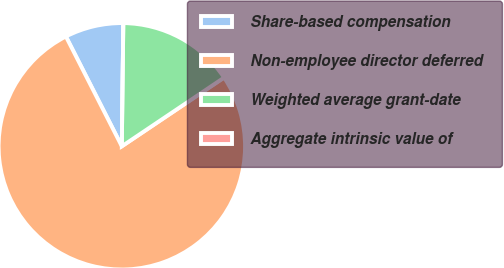Convert chart. <chart><loc_0><loc_0><loc_500><loc_500><pie_chart><fcel>Share-based compensation<fcel>Non-employee director deferred<fcel>Weighted average grant-date<fcel>Aggregate intrinsic value of<nl><fcel>7.69%<fcel>76.92%<fcel>15.39%<fcel>0.0%<nl></chart> 